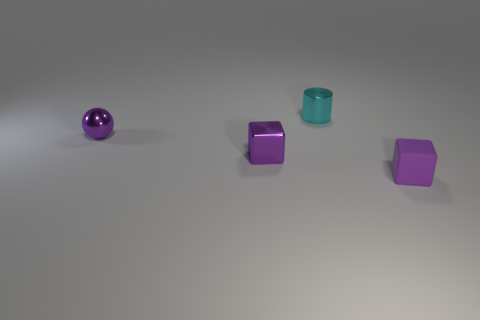Add 4 big blue metallic cylinders. How many objects exist? 8 Subtract 1 cylinders. How many cylinders are left? 0 Subtract all gray spheres. Subtract all blue cylinders. How many spheres are left? 1 Subtract all big red objects. Subtract all purple spheres. How many objects are left? 3 Add 1 cyan cylinders. How many cyan cylinders are left? 2 Add 1 yellow cylinders. How many yellow cylinders exist? 1 Subtract 0 cyan spheres. How many objects are left? 4 Subtract all spheres. How many objects are left? 3 